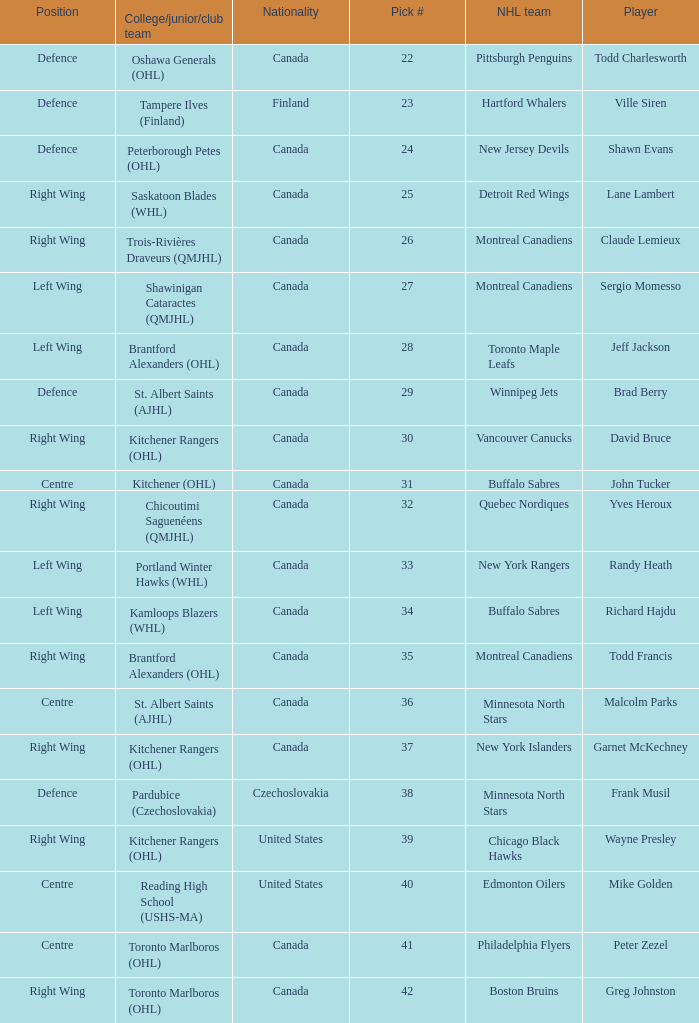How many times is the nhl team the winnipeg jets? 1.0. Can you parse all the data within this table? {'header': ['Position', 'College/junior/club team', 'Nationality', 'Pick #', 'NHL team', 'Player'], 'rows': [['Defence', 'Oshawa Generals (OHL)', 'Canada', '22', 'Pittsburgh Penguins', 'Todd Charlesworth'], ['Defence', 'Tampere Ilves (Finland)', 'Finland', '23', 'Hartford Whalers', 'Ville Siren'], ['Defence', 'Peterborough Petes (OHL)', 'Canada', '24', 'New Jersey Devils', 'Shawn Evans'], ['Right Wing', 'Saskatoon Blades (WHL)', 'Canada', '25', 'Detroit Red Wings', 'Lane Lambert'], ['Right Wing', 'Trois-Rivières Draveurs (QMJHL)', 'Canada', '26', 'Montreal Canadiens', 'Claude Lemieux'], ['Left Wing', 'Shawinigan Cataractes (QMJHL)', 'Canada', '27', 'Montreal Canadiens', 'Sergio Momesso'], ['Left Wing', 'Brantford Alexanders (OHL)', 'Canada', '28', 'Toronto Maple Leafs', 'Jeff Jackson'], ['Defence', 'St. Albert Saints (AJHL)', 'Canada', '29', 'Winnipeg Jets', 'Brad Berry'], ['Right Wing', 'Kitchener Rangers (OHL)', 'Canada', '30', 'Vancouver Canucks', 'David Bruce'], ['Centre', 'Kitchener (OHL)', 'Canada', '31', 'Buffalo Sabres', 'John Tucker'], ['Right Wing', 'Chicoutimi Saguenéens (QMJHL)', 'Canada', '32', 'Quebec Nordiques', 'Yves Heroux'], ['Left Wing', 'Portland Winter Hawks (WHL)', 'Canada', '33', 'New York Rangers', 'Randy Heath'], ['Left Wing', 'Kamloops Blazers (WHL)', 'Canada', '34', 'Buffalo Sabres', 'Richard Hajdu'], ['Right Wing', 'Brantford Alexanders (OHL)', 'Canada', '35', 'Montreal Canadiens', 'Todd Francis'], ['Centre', 'St. Albert Saints (AJHL)', 'Canada', '36', 'Minnesota North Stars', 'Malcolm Parks'], ['Right Wing', 'Kitchener Rangers (OHL)', 'Canada', '37', 'New York Islanders', 'Garnet McKechney'], ['Defence', 'Pardubice (Czechoslovakia)', 'Czechoslovakia', '38', 'Minnesota North Stars', 'Frank Musil'], ['Right Wing', 'Kitchener Rangers (OHL)', 'United States', '39', 'Chicago Black Hawks', 'Wayne Presley'], ['Centre', 'Reading High School (USHS-MA)', 'United States', '40', 'Edmonton Oilers', 'Mike Golden'], ['Centre', 'Toronto Marlboros (OHL)', 'Canada', '41', 'Philadelphia Flyers', 'Peter Zezel'], ['Right Wing', 'Toronto Marlboros (OHL)', 'Canada', '42', 'Boston Bruins', 'Greg Johnston']]} 